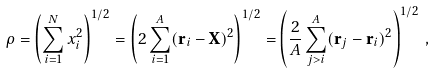<formula> <loc_0><loc_0><loc_500><loc_500>\rho = \left ( \sum _ { i = 1 } ^ { N } x _ { i } ^ { 2 } \right ) ^ { 1 / 2 } = \left ( 2 \sum _ { i = 1 } ^ { A } ( \mathbf r _ { i } - \mathbf X ) ^ { 2 } \right ) ^ { 1 / 2 } = \left ( \frac { 2 } { A } \sum _ { j > i } ^ { A } ( \mathbf r _ { j } - \mathbf r _ { i } ) ^ { 2 } \right ) ^ { 1 / 2 } \, ,</formula> 